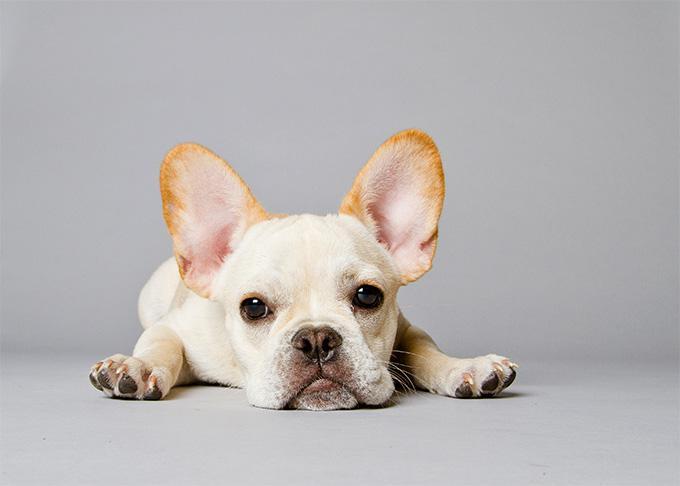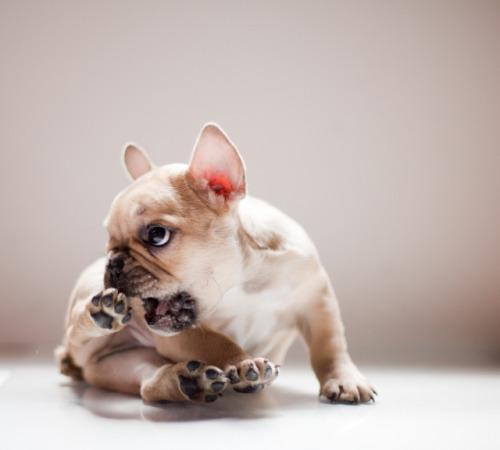The first image is the image on the left, the second image is the image on the right. Analyze the images presented: Is the assertion "In one of the images there is a single puppy lying on the floor." valid? Answer yes or no. Yes. 